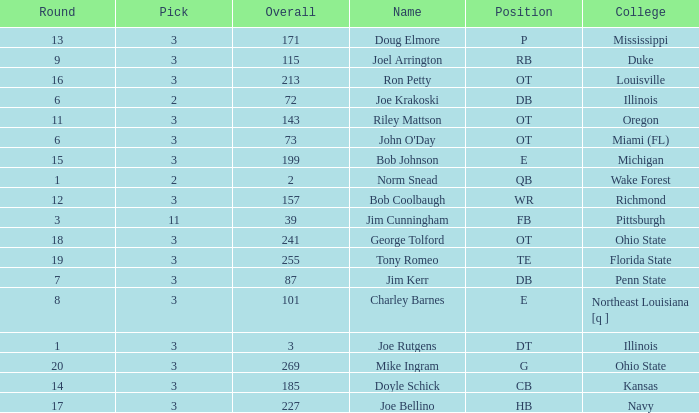How many rounds have john o'day as the name, and a pick less than 3? None. 